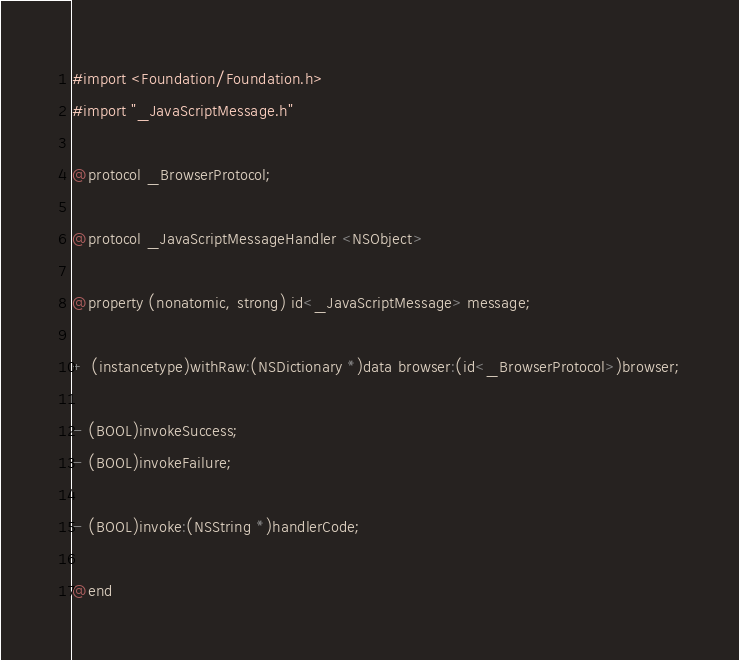<code> <loc_0><loc_0><loc_500><loc_500><_C_>#import <Foundation/Foundation.h>
#import "_JavaScriptMessage.h"

@protocol _BrowserProtocol;

@protocol _JavaScriptMessageHandler <NSObject>

@property (nonatomic, strong) id<_JavaScriptMessage> message;

+ (instancetype)withRaw:(NSDictionary *)data browser:(id<_BrowserProtocol>)browser;

- (BOOL)invokeSuccess;
- (BOOL)invokeFailure;

- (BOOL)invoke:(NSString *)handlerCode;

@end
</code> 